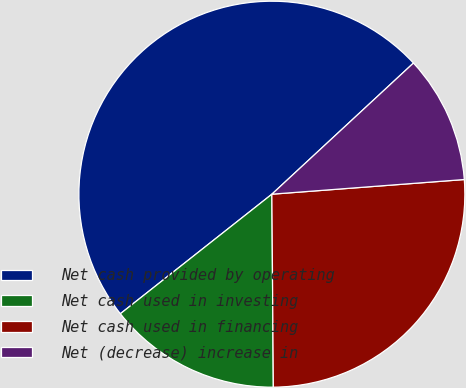<chart> <loc_0><loc_0><loc_500><loc_500><pie_chart><fcel>Net cash provided by operating<fcel>Net cash used in investing<fcel>Net cash used in financing<fcel>Net (decrease) increase in<nl><fcel>48.74%<fcel>14.49%<fcel>26.09%<fcel>10.68%<nl></chart> 